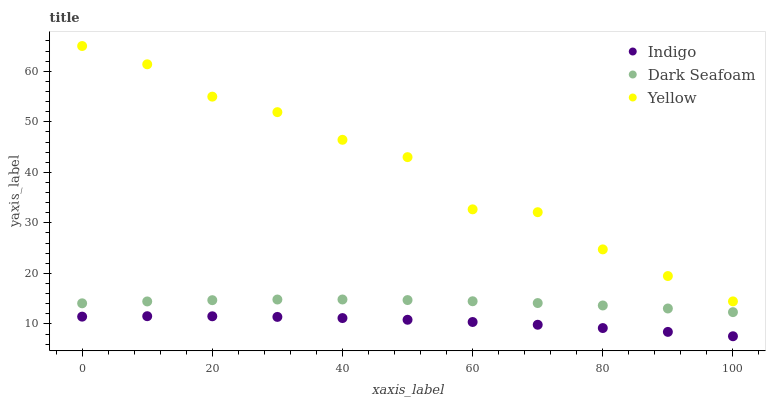Does Indigo have the minimum area under the curve?
Answer yes or no. Yes. Does Yellow have the maximum area under the curve?
Answer yes or no. Yes. Does Yellow have the minimum area under the curve?
Answer yes or no. No. Does Indigo have the maximum area under the curve?
Answer yes or no. No. Is Indigo the smoothest?
Answer yes or no. Yes. Is Yellow the roughest?
Answer yes or no. Yes. Is Yellow the smoothest?
Answer yes or no. No. Is Indigo the roughest?
Answer yes or no. No. Does Indigo have the lowest value?
Answer yes or no. Yes. Does Yellow have the lowest value?
Answer yes or no. No. Does Yellow have the highest value?
Answer yes or no. Yes. Does Indigo have the highest value?
Answer yes or no. No. Is Indigo less than Yellow?
Answer yes or no. Yes. Is Yellow greater than Dark Seafoam?
Answer yes or no. Yes. Does Indigo intersect Yellow?
Answer yes or no. No. 